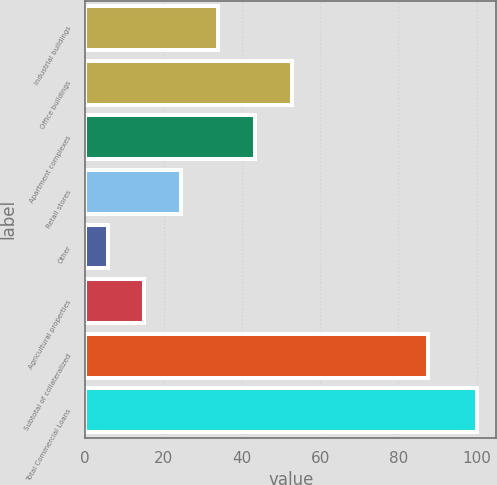<chart> <loc_0><loc_0><loc_500><loc_500><bar_chart><fcel>Industrial buildings<fcel>Office buildings<fcel>Apartment complexes<fcel>Retail stores<fcel>Other<fcel>Agricultural properties<fcel>Subtotal of collateralized<fcel>Total Commercial Loans<nl><fcel>33.99<fcel>52.85<fcel>43.42<fcel>24.56<fcel>5.7<fcel>15.13<fcel>87.7<fcel>100<nl></chart> 